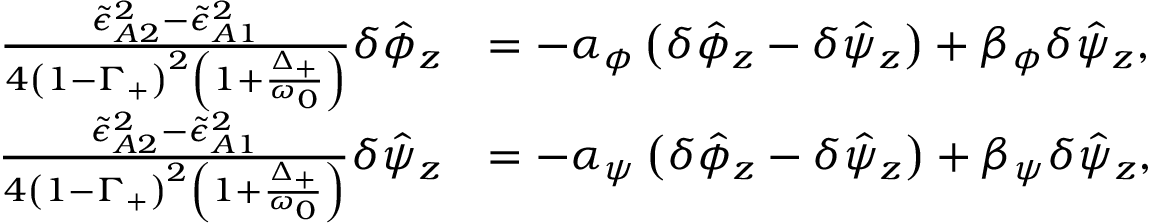<formula> <loc_0><loc_0><loc_500><loc_500>\begin{array} { r l } { \frac { \tilde { \epsilon } _ { A 2 } ^ { 2 } - \tilde { \epsilon } _ { A 1 } ^ { 2 } } { 4 \left ( 1 - \Gamma _ { + } \right ) ^ { 2 } \left ( 1 + \frac { \Delta _ { + } } { \omega _ { 0 } } \right ) } \delta \hat { \phi } _ { z } } & { = - \alpha _ { \phi } \left ( \delta \hat { \phi } _ { z } - \delta \hat { \psi } _ { z } \right ) + \beta _ { \phi } \delta \hat { \psi } _ { z } , } \\ { \frac { \tilde { \epsilon } _ { A 2 } ^ { 2 } - \tilde { \epsilon } _ { A 1 } ^ { 2 } } { 4 \left ( 1 - \Gamma _ { + } \right ) ^ { 2 } \left ( 1 + \frac { \Delta _ { + } } { \omega _ { 0 } } \right ) } \delta \hat { \psi } _ { z } } & { = - \alpha _ { \psi } \left ( \delta \hat { \phi } _ { z } - \delta \hat { \psi } _ { z } \right ) + \beta _ { \psi } \delta \hat { \psi } _ { z } , } \end{array}</formula> 